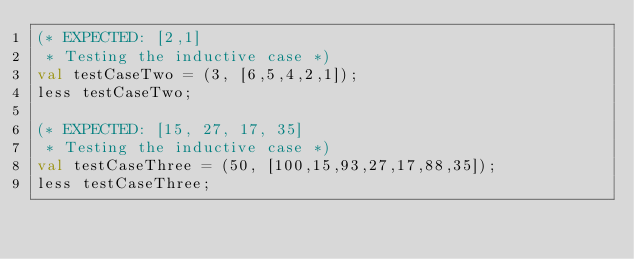<code> <loc_0><loc_0><loc_500><loc_500><_SML_>(* EXPECTED: [2,1]
 * Testing the inductive case *)
val testCaseTwo = (3, [6,5,4,2,1]);
less testCaseTwo;

(* EXPECTED: [15, 27, 17, 35]
 * Testing the inductive case *)
val testCaseThree = (50, [100,15,93,27,17,88,35]);
less testCaseThree;</code> 